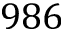<formula> <loc_0><loc_0><loc_500><loc_500>9 8 6</formula> 